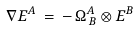<formula> <loc_0><loc_0><loc_500><loc_500>\nabla E ^ { A } \, = \, - \, \Omega _ { \, B } ^ { A } \otimes E ^ { B }</formula> 